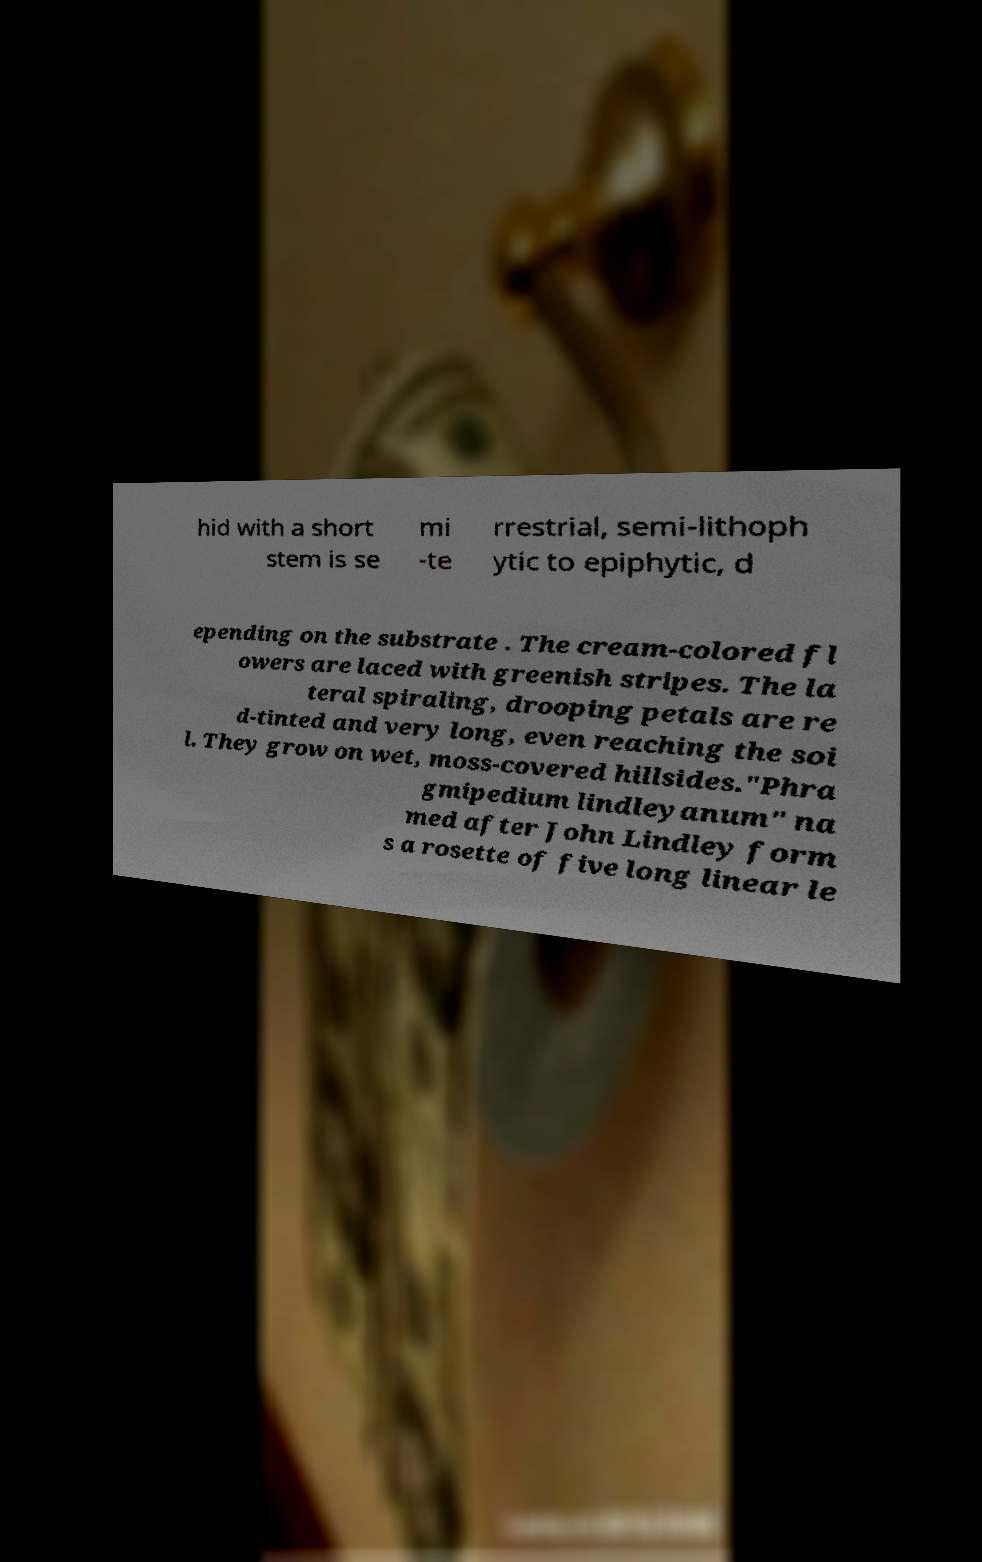Can you accurately transcribe the text from the provided image for me? hid with a short stem is se mi -te rrestrial, semi-lithoph ytic to epiphytic, d epending on the substrate . The cream-colored fl owers are laced with greenish stripes. The la teral spiraling, drooping petals are re d-tinted and very long, even reaching the soi l. They grow on wet, moss-covered hillsides."Phra gmipedium lindleyanum" na med after John Lindley form s a rosette of five long linear le 